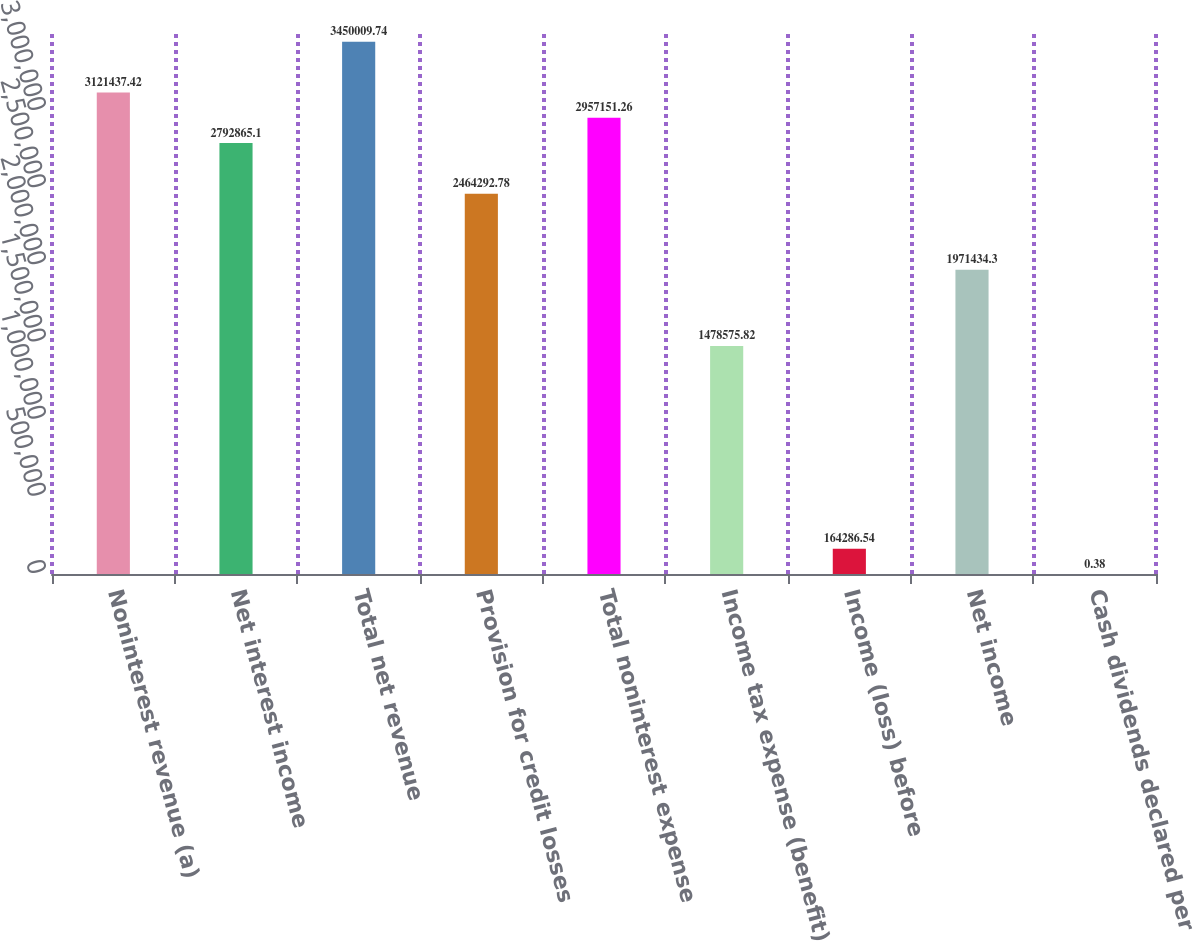Convert chart. <chart><loc_0><loc_0><loc_500><loc_500><bar_chart><fcel>Noninterest revenue (a)<fcel>Net interest income<fcel>Total net revenue<fcel>Provision for credit losses<fcel>Total noninterest expense<fcel>Income tax expense (benefit)<fcel>Income (loss) before<fcel>Net income<fcel>Cash dividends declared per<nl><fcel>3.12144e+06<fcel>2.79287e+06<fcel>3.45001e+06<fcel>2.46429e+06<fcel>2.95715e+06<fcel>1.47858e+06<fcel>164287<fcel>1.97143e+06<fcel>0.38<nl></chart> 